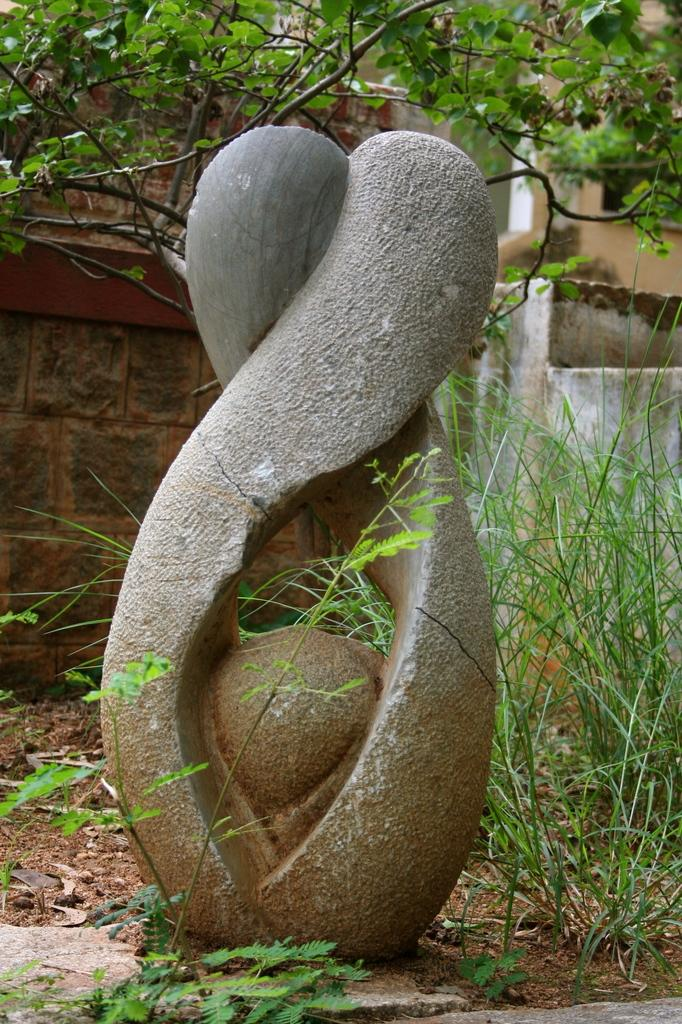What type of natural elements can be seen in the image? There are trees in the image. Can you describe the object in the image? Unfortunately, there is not enough information provided to describe the object in the image. What type of voyage is depicted in the image? There is no voyage depicted in the image; it only features trees and an unidentified object. How many soldiers are present in the image? There is no army or soldiers present in the image; it only features trees and an unidentified object. 